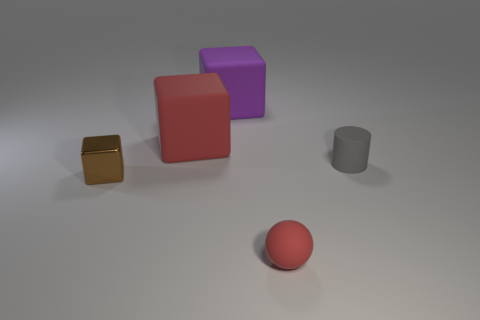What is the texture of the objects in the image? The objects in the image have a matte finish with subtle reflections, indicating a non-glossy surface texture that doesn't produce sharp specular highlights. 